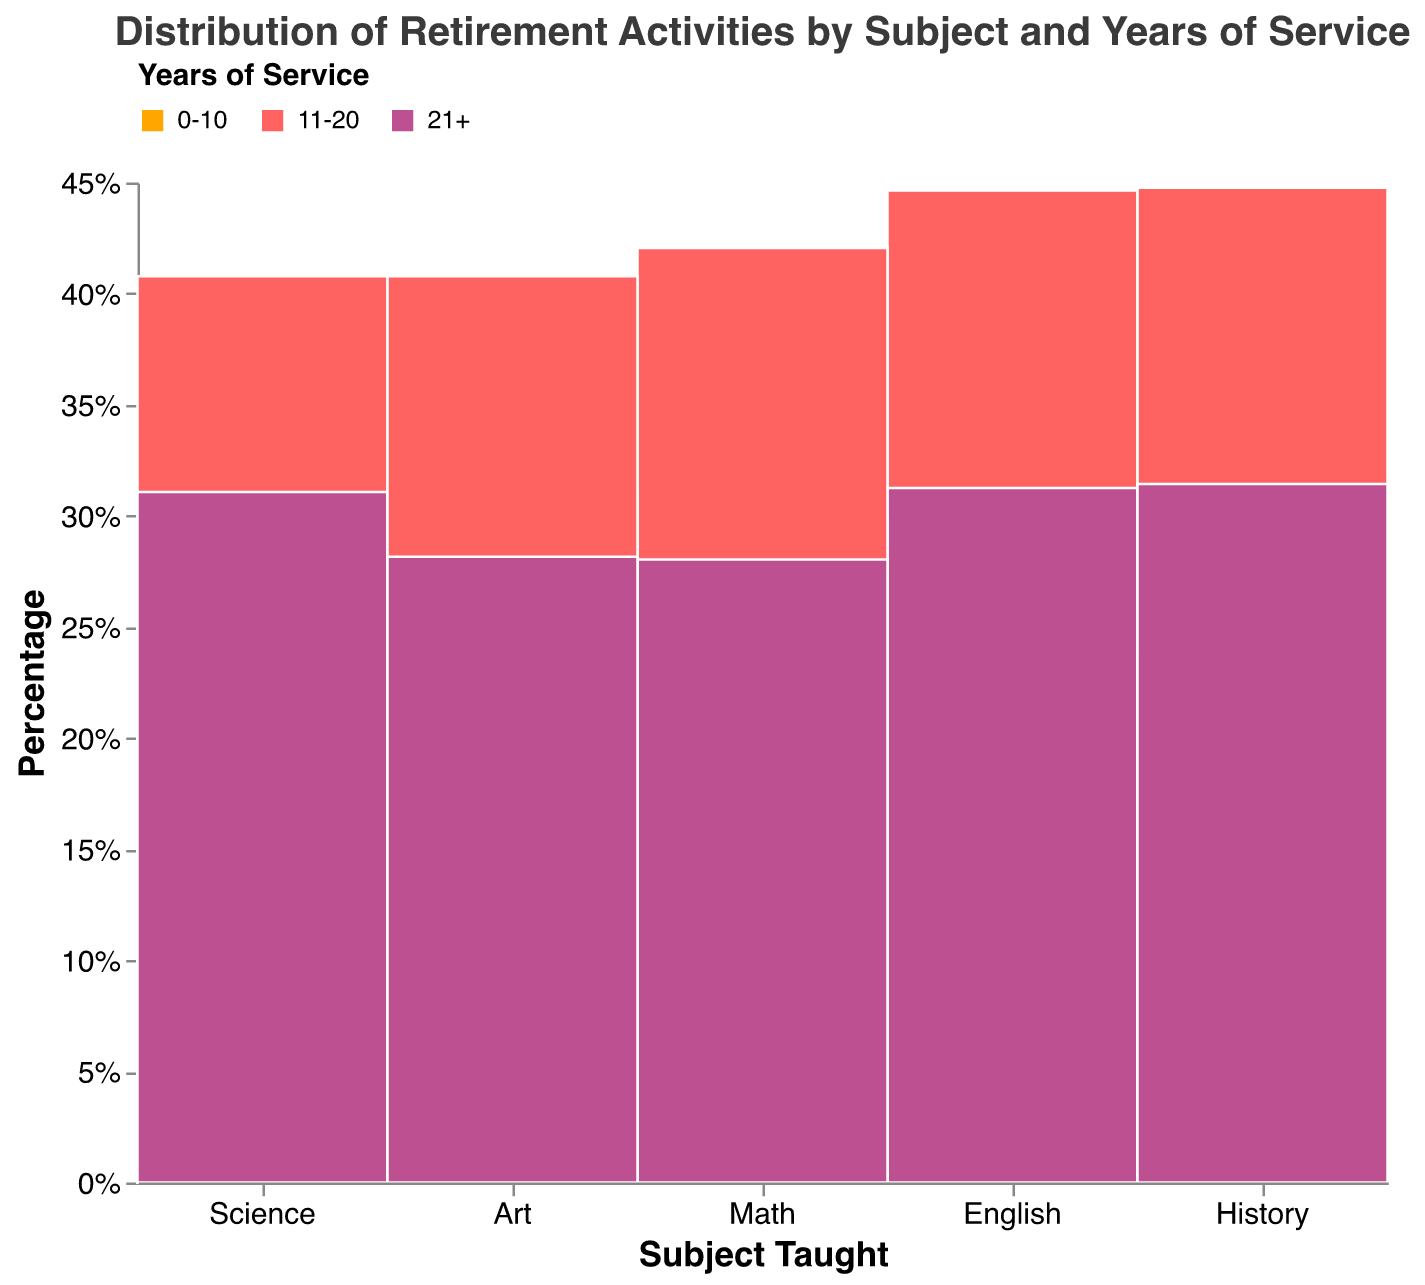What is the title of the figure? The title of the figure is displayed at the top and reads "Distribution of Retirement Activities by Subject and Years of Service."
Answer: Distribution of Retirement Activities by Subject and Years of Service Which subject has the highest percentage of retired educators with 21+ years of service? To determine this, look at the height of the "21+" colored sections within each subject. The subject with the tallest section in this color has the highest percentage.
Answer: English Which subject has the most varied distribution of retirement activities? To answer this, look at the different heights of colored segments within each subject. The subject with the most mixed heights across its segments has the most varied distribution.
Answer: Art For English educators with 0-10 years of service, which retirement activity has the highest count? Referring to the tooltip information for English with 0-10 years of service, the highest count retirement activity can be seen in the "Travel" section.
Answer: Travel Compare the proportion of educators in Math and Science who have 11-20 years of service. Which has a higher percentage? Look at the height of the "11-20" colored sections in the Math and Science columns. The subject with the taller section in this color has the higher percentage.
Answer: Math What percentage of History educators have 21+ years of service? Hover over the "21+" section of the History column to see the tooltip displaying the "PercentOfSubject" for that segment.
Answer: 41.3% Which retirement activity is the most popular among educators with 21+ years of service across all subjects? To find this, identify the common activity with the largest segment height within the "21+" colored sections across all subjects.
Answer: Mentoring Which subject shows the highest proportion of retired educators with 11-20 years of service engaged in community-focused activities? Look for community-focused activities like Book Club, Museum Docent, and Historical Society among educators with "11-20" years of service. The subject with the largest segment in these categories has the highest proportion.
Answer: Art Find the percentage of Science educators with 0-10 years of service engaged in Nature Walks. Hover over the "0-10" section for Science to find the "Nature Walks" segment and check its "PercentOfSubject" tooltip value.
Answer: 23.5% How does the proportion of retired Math educators involved in Financial Planning compare to those in Puzzles among those with 11-20 years of service? Check the heights of the "Financial Planning" and "Puzzles" segments within the "11-20" section for Math. "Puzzles" will have a taller section.
Answer: Higher proportion in Puzzles 